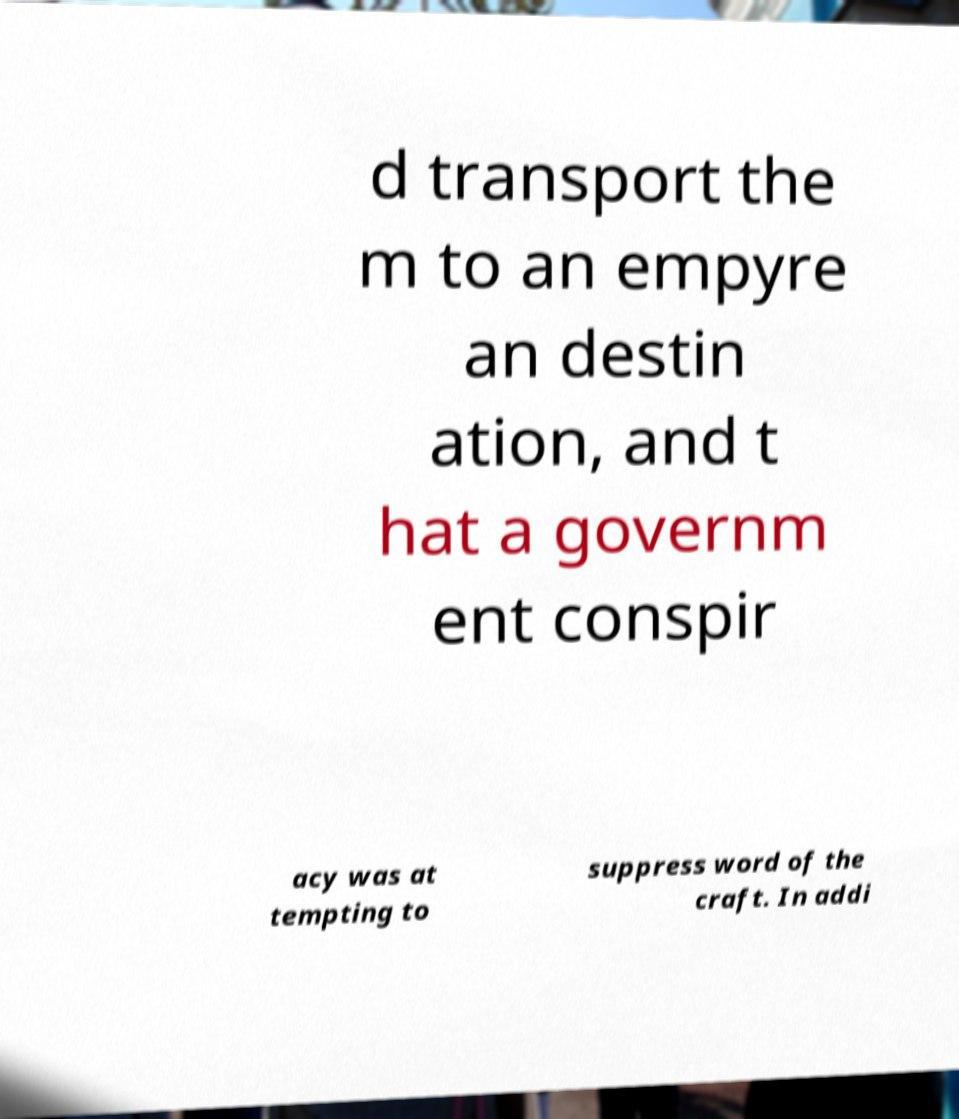What messages or text are displayed in this image? I need them in a readable, typed format. d transport the m to an empyre an destin ation, and t hat a governm ent conspir acy was at tempting to suppress word of the craft. In addi 